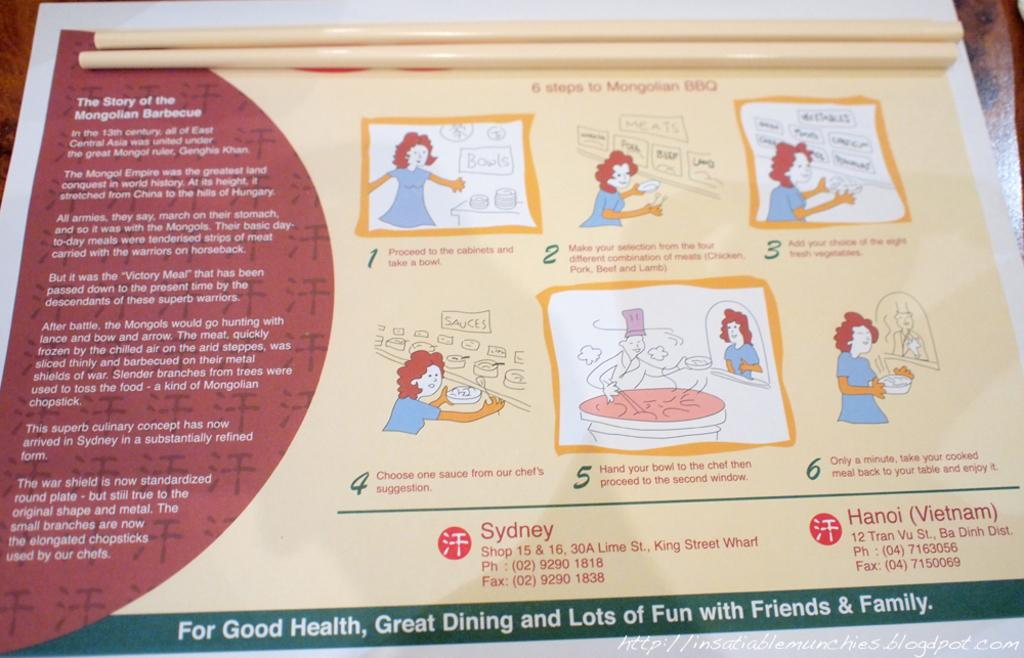What is the color of the surface in the image? The surface in the image is brown. What is placed on the brown surface? There is a poster on the brown surface. Can you describe the colors of the poster? The poster is cream, white, and red in color. How many cream colored objects are on the poster? There are two cream colored objects on the poster. How does the poster affect the driving experience in the image? The image does not depict a driving experience, nor does it show any vehicles or roads. 